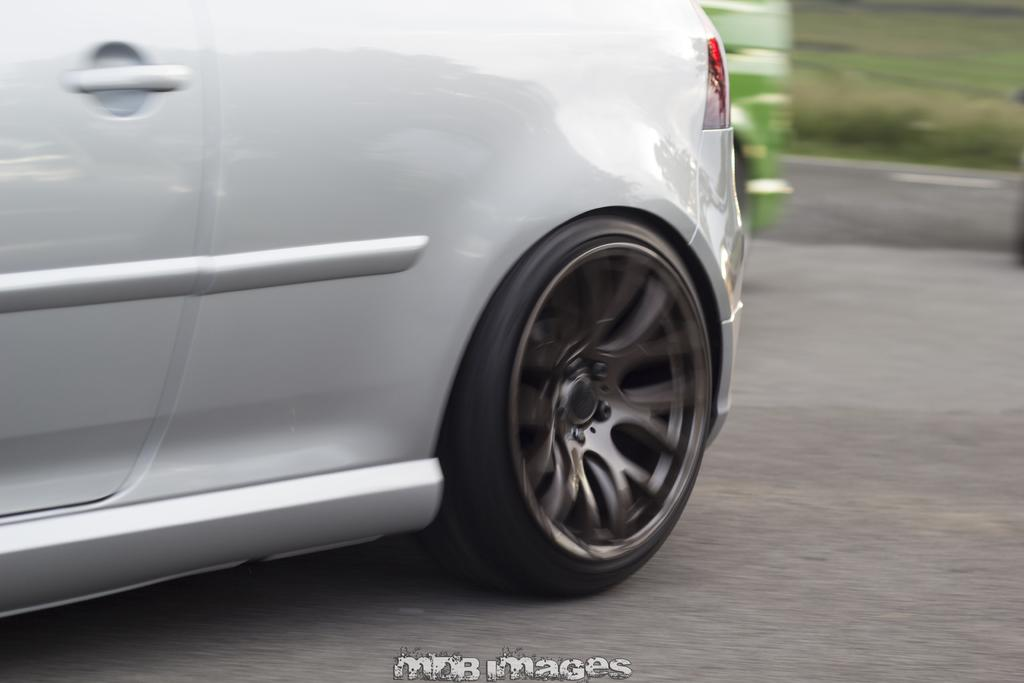What can be seen on the road in the image? There are vehicles on the road in the image. What type of vegetation is visible in the image? There is grass visible in the image. What is located at the bottom of the image? There is text at the bottom of the image. Can you tell me how many balls are rolling on the grass in the picture? There is no ball present in the image; it only features vehicles on the road and grass. What route are the vehicles taking in the image? The image does not provide information about the route the vehicles are taking; it only shows them on the road. 